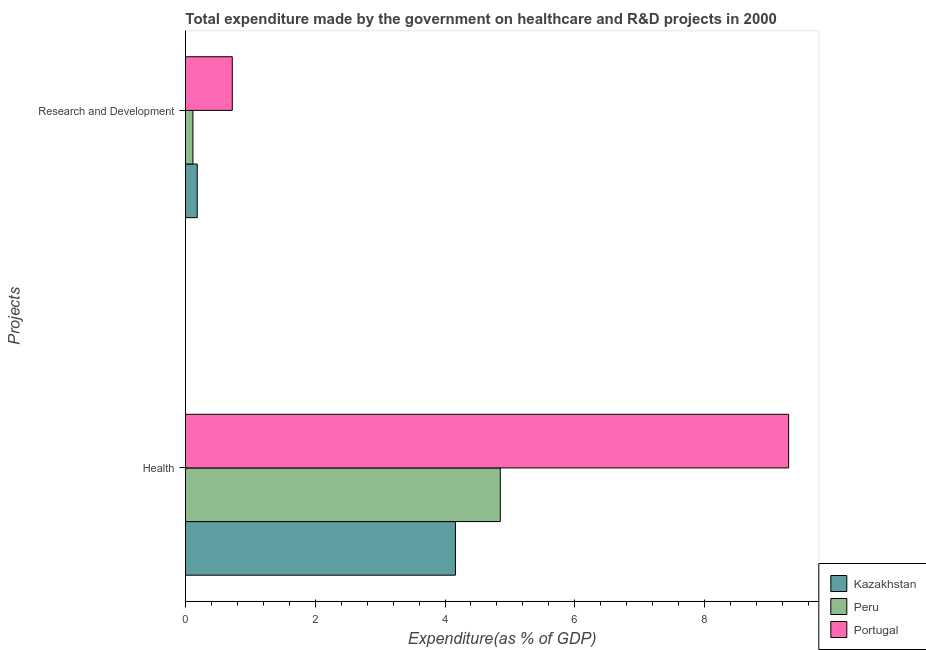How many different coloured bars are there?
Your response must be concise. 3. How many bars are there on the 2nd tick from the bottom?
Offer a terse response. 3. What is the label of the 2nd group of bars from the top?
Your response must be concise. Health. What is the expenditure in healthcare in Peru?
Give a very brief answer. 4.85. Across all countries, what is the maximum expenditure in r&d?
Make the answer very short. 0.72. Across all countries, what is the minimum expenditure in healthcare?
Provide a short and direct response. 4.16. In which country was the expenditure in healthcare minimum?
Your response must be concise. Kazakhstan. What is the total expenditure in healthcare in the graph?
Give a very brief answer. 18.31. What is the difference between the expenditure in healthcare in Kazakhstan and that in Portugal?
Your answer should be compact. -5.14. What is the difference between the expenditure in healthcare in Kazakhstan and the expenditure in r&d in Peru?
Give a very brief answer. 4.05. What is the average expenditure in r&d per country?
Make the answer very short. 0.34. What is the difference between the expenditure in r&d and expenditure in healthcare in Portugal?
Your answer should be very brief. -8.58. In how many countries, is the expenditure in r&d greater than 6.8 %?
Offer a terse response. 0. What is the ratio of the expenditure in healthcare in Kazakhstan to that in Portugal?
Provide a succinct answer. 0.45. Is the expenditure in r&d in Kazakhstan less than that in Peru?
Offer a terse response. No. In how many countries, is the expenditure in healthcare greater than the average expenditure in healthcare taken over all countries?
Offer a terse response. 1. What does the 2nd bar from the top in Research and Development represents?
Offer a very short reply. Peru. What does the 1st bar from the bottom in Research and Development represents?
Offer a terse response. Kazakhstan. How many bars are there?
Your answer should be compact. 6. Are all the bars in the graph horizontal?
Your answer should be very brief. Yes. What is the difference between two consecutive major ticks on the X-axis?
Give a very brief answer. 2. Does the graph contain any zero values?
Your answer should be compact. No. Where does the legend appear in the graph?
Offer a terse response. Bottom right. How many legend labels are there?
Keep it short and to the point. 3. What is the title of the graph?
Offer a very short reply. Total expenditure made by the government on healthcare and R&D projects in 2000. What is the label or title of the X-axis?
Offer a terse response. Expenditure(as % of GDP). What is the label or title of the Y-axis?
Provide a short and direct response. Projects. What is the Expenditure(as % of GDP) in Kazakhstan in Health?
Offer a very short reply. 4.16. What is the Expenditure(as % of GDP) in Peru in Health?
Your answer should be compact. 4.85. What is the Expenditure(as % of GDP) in Portugal in Health?
Your answer should be compact. 9.3. What is the Expenditure(as % of GDP) of Kazakhstan in Research and Development?
Offer a very short reply. 0.18. What is the Expenditure(as % of GDP) of Peru in Research and Development?
Give a very brief answer. 0.11. What is the Expenditure(as % of GDP) of Portugal in Research and Development?
Provide a succinct answer. 0.72. Across all Projects, what is the maximum Expenditure(as % of GDP) of Kazakhstan?
Your answer should be very brief. 4.16. Across all Projects, what is the maximum Expenditure(as % of GDP) in Peru?
Provide a short and direct response. 4.85. Across all Projects, what is the maximum Expenditure(as % of GDP) of Portugal?
Give a very brief answer. 9.3. Across all Projects, what is the minimum Expenditure(as % of GDP) of Kazakhstan?
Give a very brief answer. 0.18. Across all Projects, what is the minimum Expenditure(as % of GDP) in Peru?
Provide a succinct answer. 0.11. Across all Projects, what is the minimum Expenditure(as % of GDP) of Portugal?
Your answer should be compact. 0.72. What is the total Expenditure(as % of GDP) in Kazakhstan in the graph?
Provide a short and direct response. 4.34. What is the total Expenditure(as % of GDP) in Peru in the graph?
Offer a terse response. 4.97. What is the total Expenditure(as % of GDP) of Portugal in the graph?
Your answer should be compact. 10.02. What is the difference between the Expenditure(as % of GDP) of Kazakhstan in Health and that in Research and Development?
Ensure brevity in your answer.  3.98. What is the difference between the Expenditure(as % of GDP) in Peru in Health and that in Research and Development?
Give a very brief answer. 4.74. What is the difference between the Expenditure(as % of GDP) in Portugal in Health and that in Research and Development?
Offer a terse response. 8.57. What is the difference between the Expenditure(as % of GDP) in Kazakhstan in Health and the Expenditure(as % of GDP) in Peru in Research and Development?
Your answer should be compact. 4.05. What is the difference between the Expenditure(as % of GDP) in Kazakhstan in Health and the Expenditure(as % of GDP) in Portugal in Research and Development?
Make the answer very short. 3.44. What is the difference between the Expenditure(as % of GDP) of Peru in Health and the Expenditure(as % of GDP) of Portugal in Research and Development?
Provide a succinct answer. 4.13. What is the average Expenditure(as % of GDP) in Kazakhstan per Projects?
Provide a short and direct response. 2.17. What is the average Expenditure(as % of GDP) of Peru per Projects?
Your answer should be very brief. 2.48. What is the average Expenditure(as % of GDP) in Portugal per Projects?
Provide a short and direct response. 5.01. What is the difference between the Expenditure(as % of GDP) in Kazakhstan and Expenditure(as % of GDP) in Peru in Health?
Provide a short and direct response. -0.69. What is the difference between the Expenditure(as % of GDP) of Kazakhstan and Expenditure(as % of GDP) of Portugal in Health?
Keep it short and to the point. -5.14. What is the difference between the Expenditure(as % of GDP) in Peru and Expenditure(as % of GDP) in Portugal in Health?
Offer a very short reply. -4.44. What is the difference between the Expenditure(as % of GDP) in Kazakhstan and Expenditure(as % of GDP) in Peru in Research and Development?
Offer a very short reply. 0.07. What is the difference between the Expenditure(as % of GDP) in Kazakhstan and Expenditure(as % of GDP) in Portugal in Research and Development?
Provide a succinct answer. -0.54. What is the difference between the Expenditure(as % of GDP) in Peru and Expenditure(as % of GDP) in Portugal in Research and Development?
Your response must be concise. -0.61. What is the ratio of the Expenditure(as % of GDP) of Kazakhstan in Health to that in Research and Development?
Your answer should be very brief. 22.98. What is the ratio of the Expenditure(as % of GDP) in Peru in Health to that in Research and Development?
Offer a very short reply. 42.43. What is the ratio of the Expenditure(as % of GDP) in Portugal in Health to that in Research and Development?
Ensure brevity in your answer.  12.89. What is the difference between the highest and the second highest Expenditure(as % of GDP) in Kazakhstan?
Provide a succinct answer. 3.98. What is the difference between the highest and the second highest Expenditure(as % of GDP) of Peru?
Keep it short and to the point. 4.74. What is the difference between the highest and the second highest Expenditure(as % of GDP) in Portugal?
Offer a terse response. 8.57. What is the difference between the highest and the lowest Expenditure(as % of GDP) of Kazakhstan?
Make the answer very short. 3.98. What is the difference between the highest and the lowest Expenditure(as % of GDP) of Peru?
Ensure brevity in your answer.  4.74. What is the difference between the highest and the lowest Expenditure(as % of GDP) of Portugal?
Your answer should be compact. 8.57. 